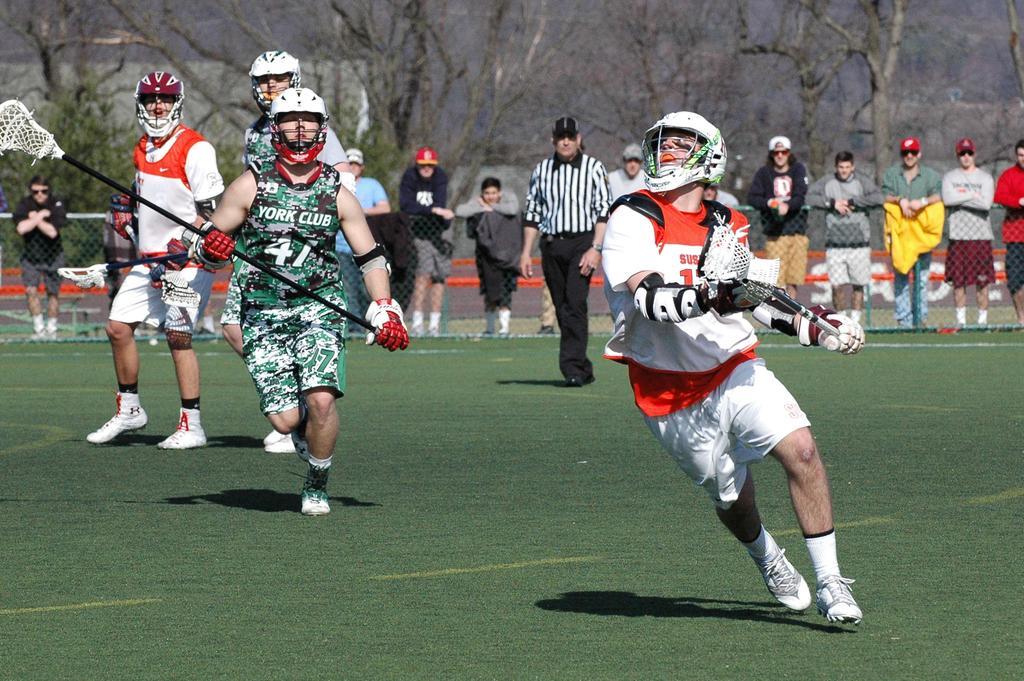In one or two sentences, can you explain what this image depicts? In the image there are few persons walking and running on the grass land, they holding a net which mounted to a pole, they had helmets over their heads and shoe to feet, this seems to be a game, in the background there are many people standing behind the fence and over the whole background there are trees. 